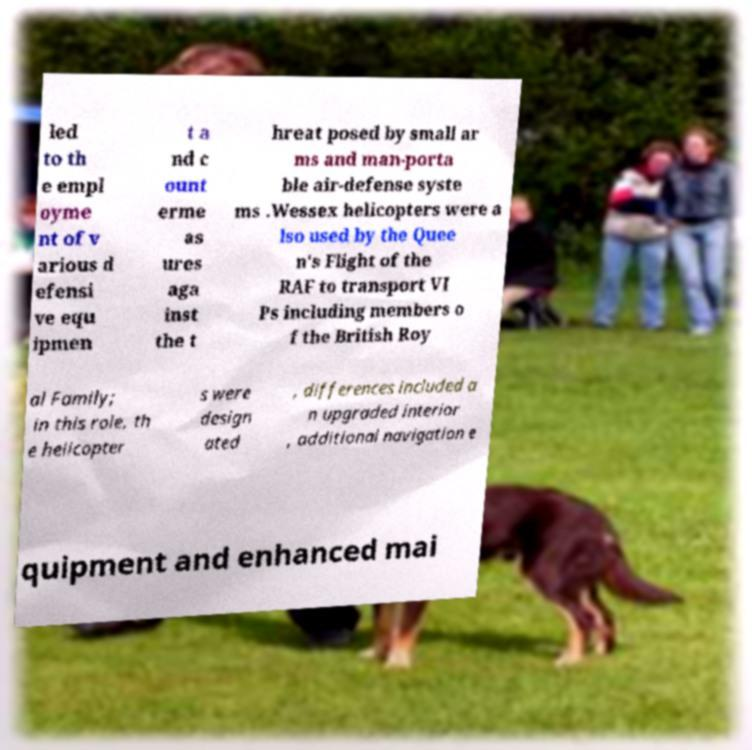Can you accurately transcribe the text from the provided image for me? led to th e empl oyme nt of v arious d efensi ve equ ipmen t a nd c ount erme as ures aga inst the t hreat posed by small ar ms and man-porta ble air-defense syste ms .Wessex helicopters were a lso used by the Quee n's Flight of the RAF to transport VI Ps including members o f the British Roy al Family; in this role, th e helicopter s were design ated , differences included a n upgraded interior , additional navigation e quipment and enhanced mai 